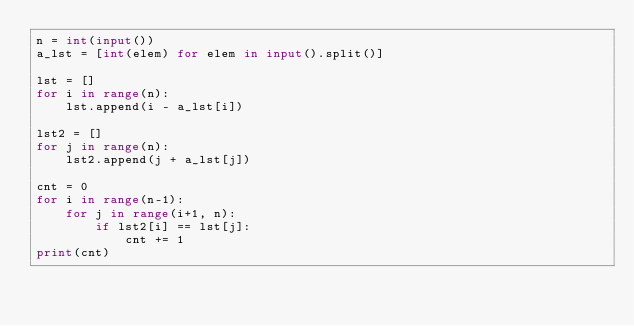Convert code to text. <code><loc_0><loc_0><loc_500><loc_500><_Python_>n = int(input())
a_lst = [int(elem) for elem in input().split()]

lst = []
for i in range(n):
    lst.append(i - a_lst[i])

lst2 = []
for j in range(n):
    lst2.append(j + a_lst[j])

cnt = 0
for i in range(n-1):
    for j in range(i+1, n):
        if lst2[i] == lst[j]:
            cnt += 1
print(cnt)

</code> 